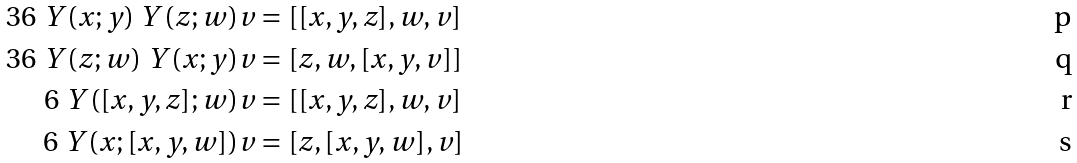<formula> <loc_0><loc_0><loc_500><loc_500>3 6 \ Y ( x ; y ) \ Y ( z ; w ) v & = [ [ x , y , z ] , w , v ] \\ 3 6 \ Y ( z ; w ) \ Y ( x ; y ) v & = [ z , w , [ x , y , v ] ] \\ 6 \ Y ( [ x , y , z ] ; w ) v & = [ [ x , y , z ] , w , v ] \\ 6 \ Y ( x ; [ x , y , w ] ) v & = [ z , [ x , y , w ] , v ]</formula> 